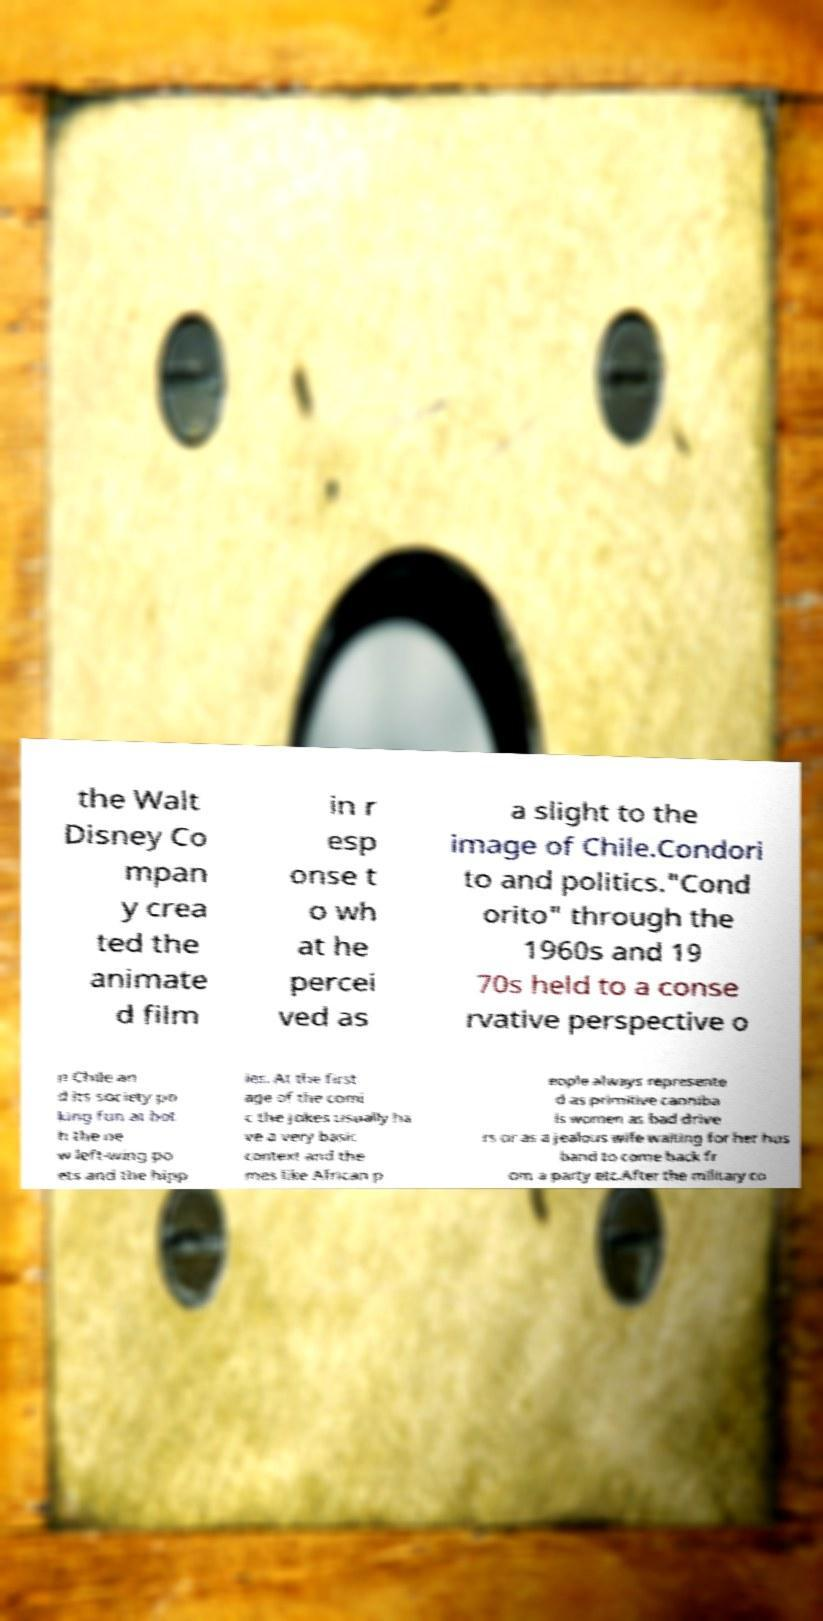Could you extract and type out the text from this image? the Walt Disney Co mpan y crea ted the animate d film in r esp onse t o wh at he percei ved as a slight to the image of Chile.Condori to and politics."Cond orito" through the 1960s and 19 70s held to a conse rvative perspective o n Chile an d its society po king fun at bot h the ne w left-wing po ets and the hipp ies. At the first age of the comi c the jokes usually ha ve a very basic context and the mes like African p eople always represente d as primitive canniba ls women as bad drive rs or as a jealous wife waiting for her hus band to come back fr om a party etc.After the military co 